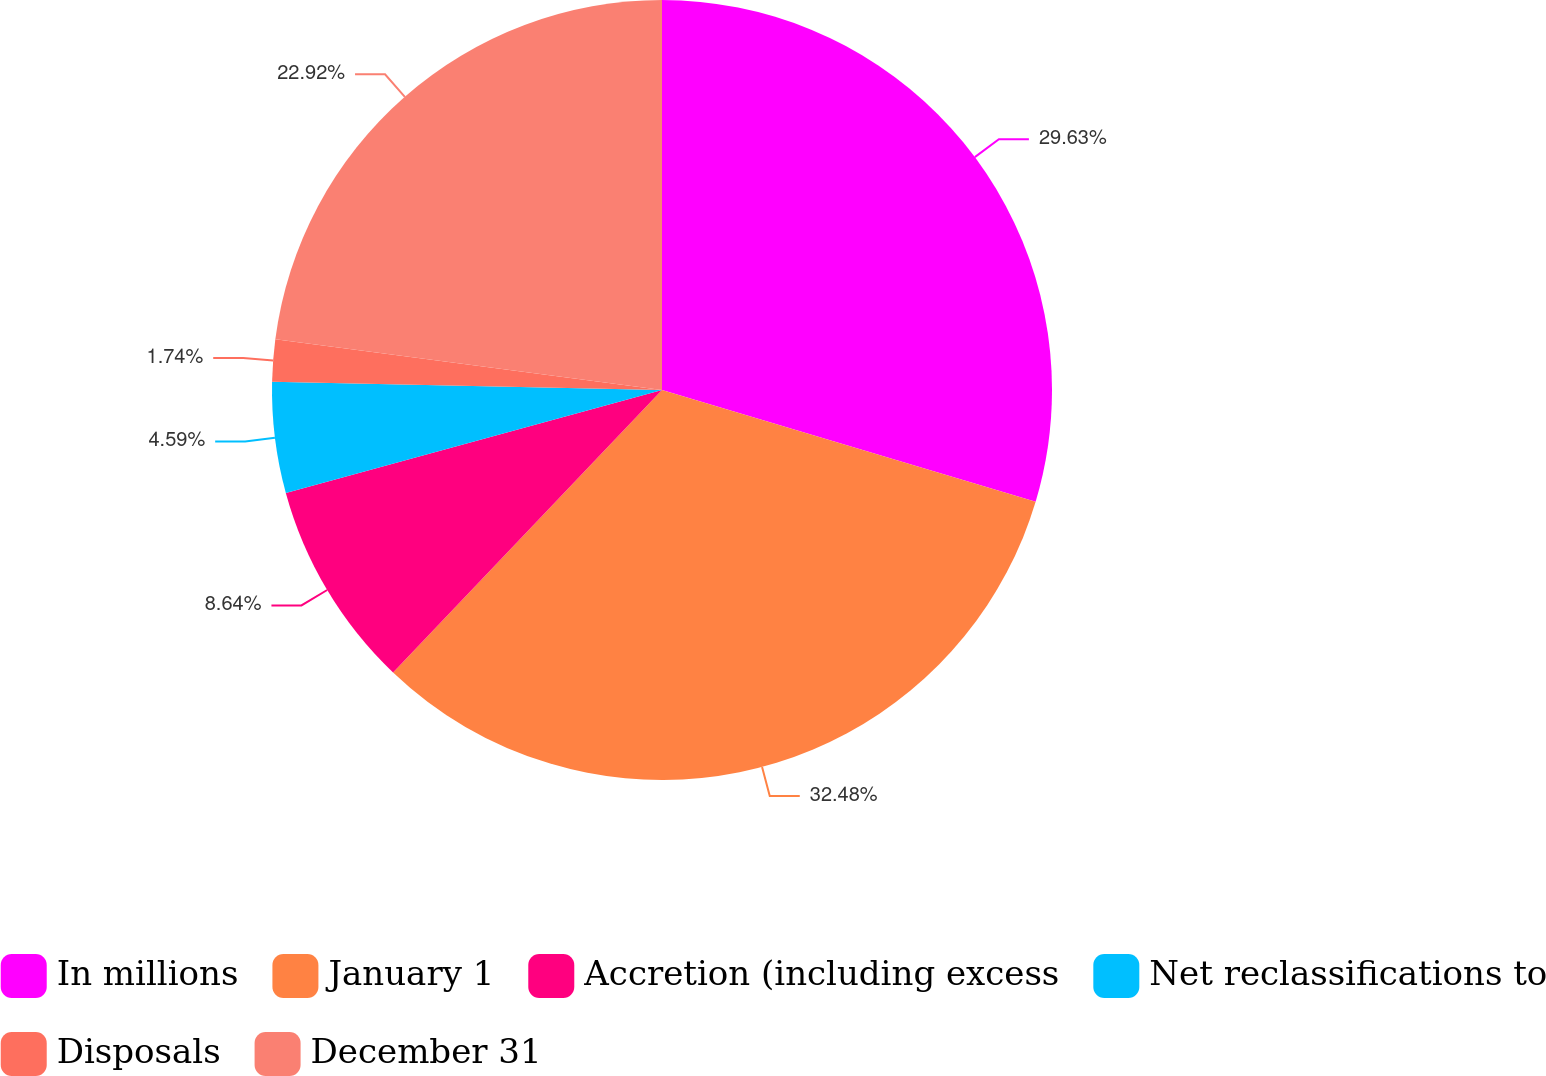<chart> <loc_0><loc_0><loc_500><loc_500><pie_chart><fcel>In millions<fcel>January 1<fcel>Accretion (including excess<fcel>Net reclassifications to<fcel>Disposals<fcel>December 31<nl><fcel>29.63%<fcel>32.48%<fcel>8.64%<fcel>4.59%<fcel>1.74%<fcel>22.92%<nl></chart> 